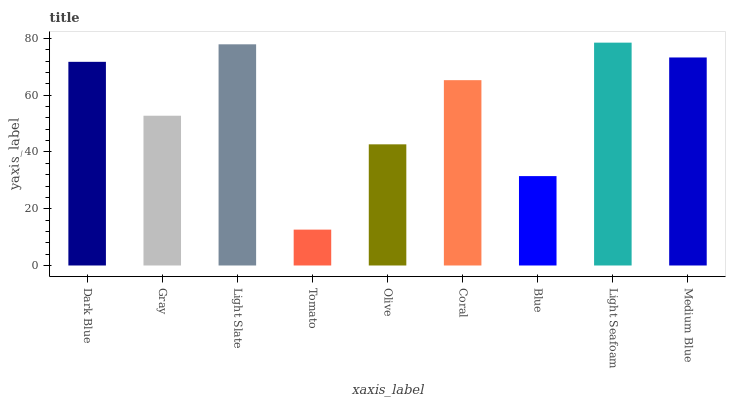Is Tomato the minimum?
Answer yes or no. Yes. Is Light Seafoam the maximum?
Answer yes or no. Yes. Is Gray the minimum?
Answer yes or no. No. Is Gray the maximum?
Answer yes or no. No. Is Dark Blue greater than Gray?
Answer yes or no. Yes. Is Gray less than Dark Blue?
Answer yes or no. Yes. Is Gray greater than Dark Blue?
Answer yes or no. No. Is Dark Blue less than Gray?
Answer yes or no. No. Is Coral the high median?
Answer yes or no. Yes. Is Coral the low median?
Answer yes or no. Yes. Is Medium Blue the high median?
Answer yes or no. No. Is Light Seafoam the low median?
Answer yes or no. No. 